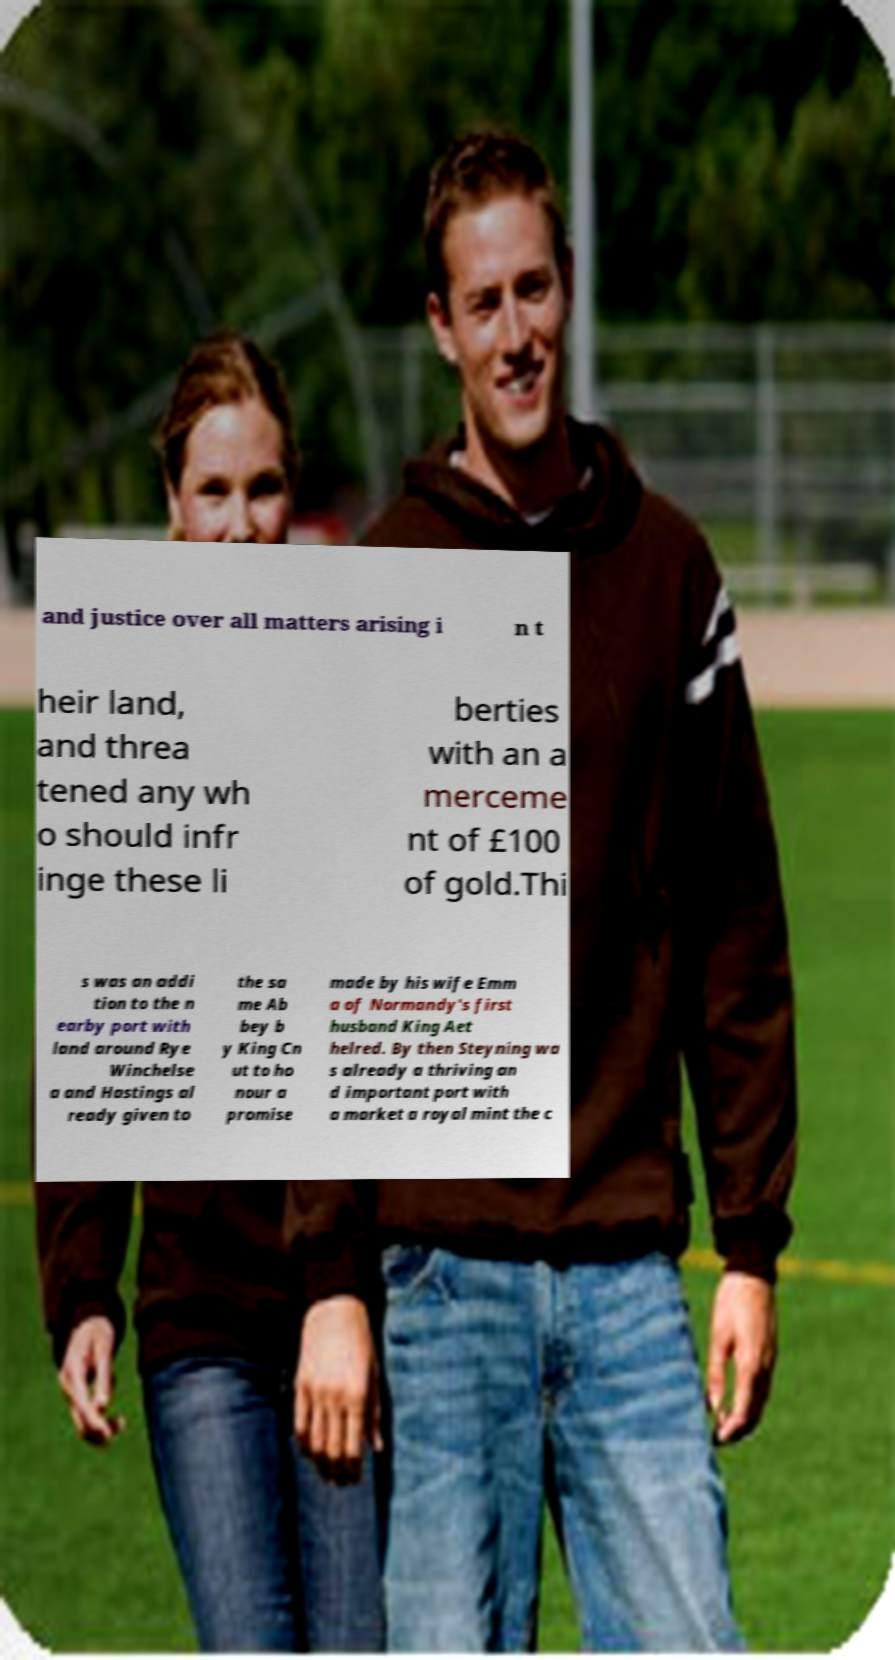Please identify and transcribe the text found in this image. and justice over all matters arising i n t heir land, and threa tened any wh o should infr inge these li berties with an a merceme nt of £100 of gold.Thi s was an addi tion to the n earby port with land around Rye Winchelse a and Hastings al ready given to the sa me Ab bey b y King Cn ut to ho nour a promise made by his wife Emm a of Normandy's first husband King Aet helred. By then Steyning wa s already a thriving an d important port with a market a royal mint the c 